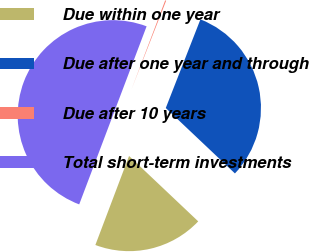Convert chart. <chart><loc_0><loc_0><loc_500><loc_500><pie_chart><fcel>Due within one year<fcel>Due after one year and through<fcel>Due after 10 years<fcel>Total short-term investments<nl><fcel>18.7%<fcel>31.12%<fcel>0.17%<fcel>50.0%<nl></chart> 